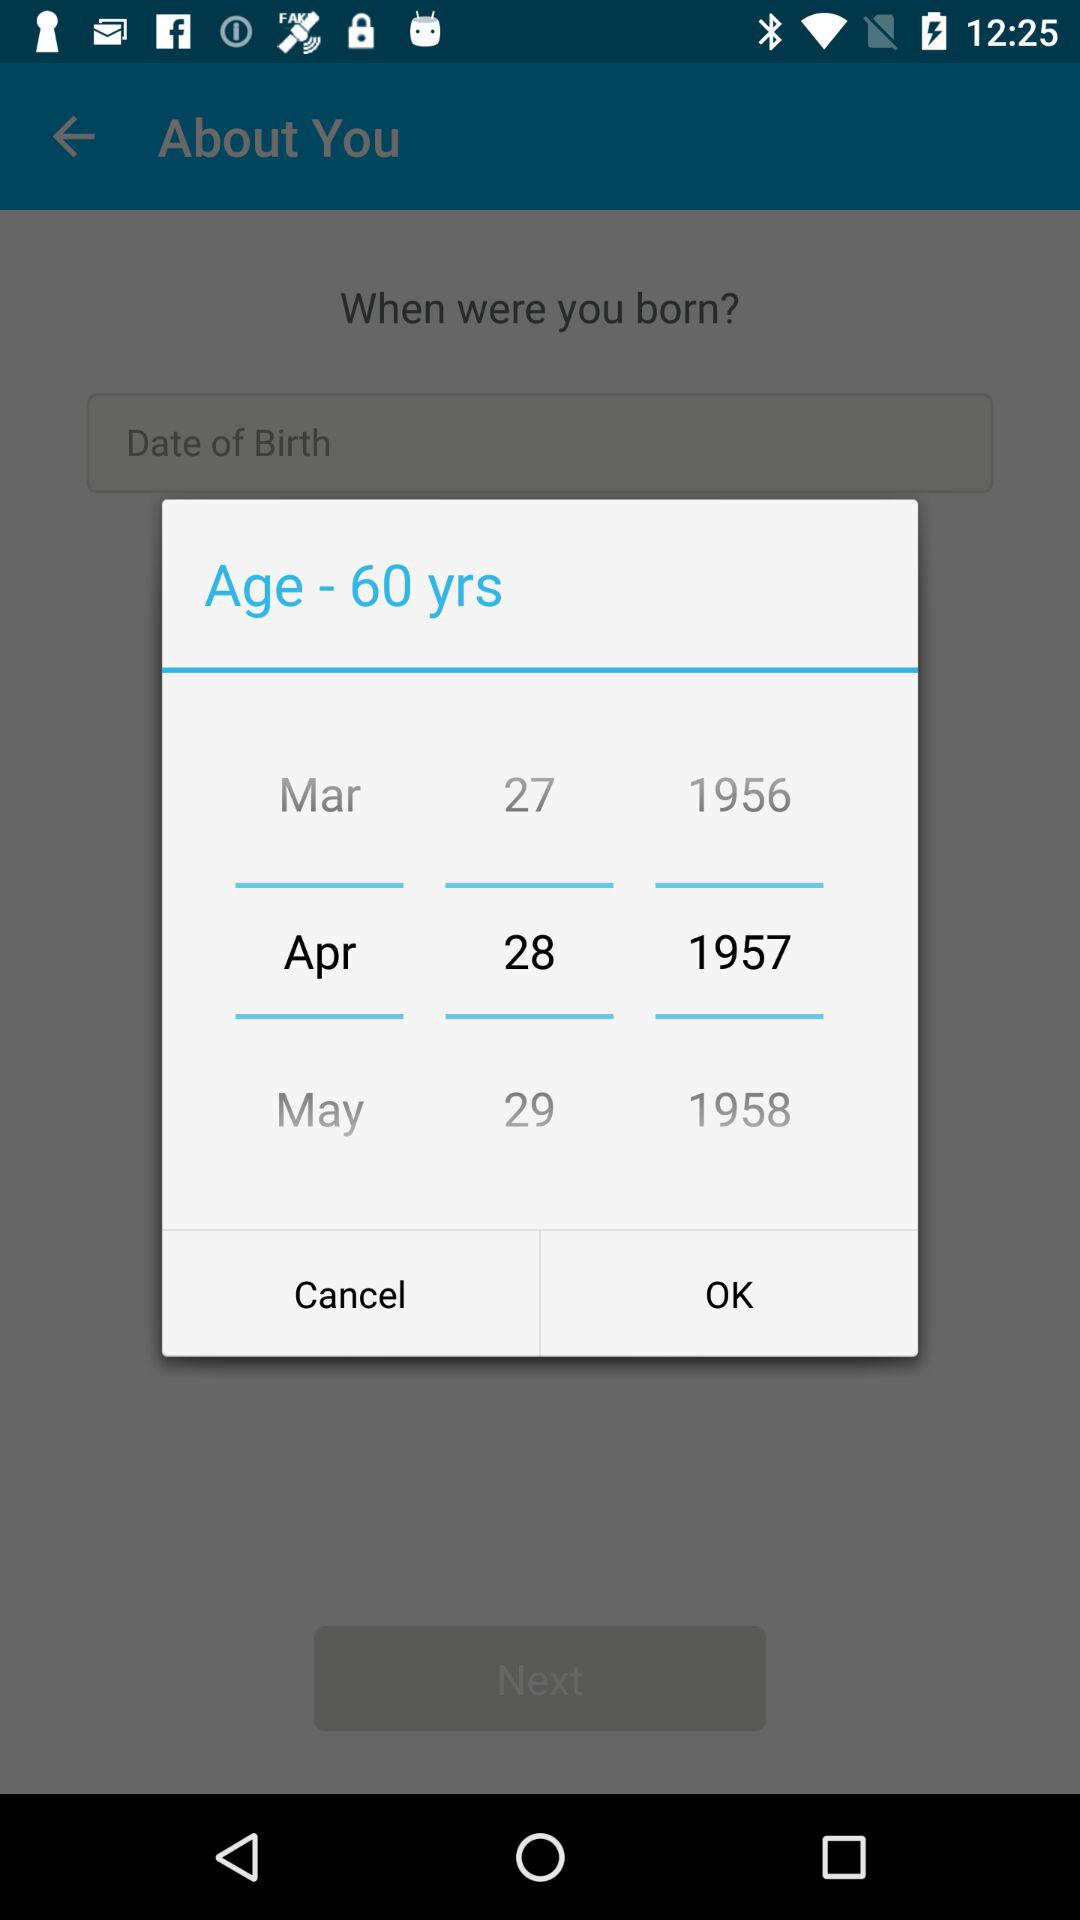What date is selected in the calendar? The date is April 28, 1957. 